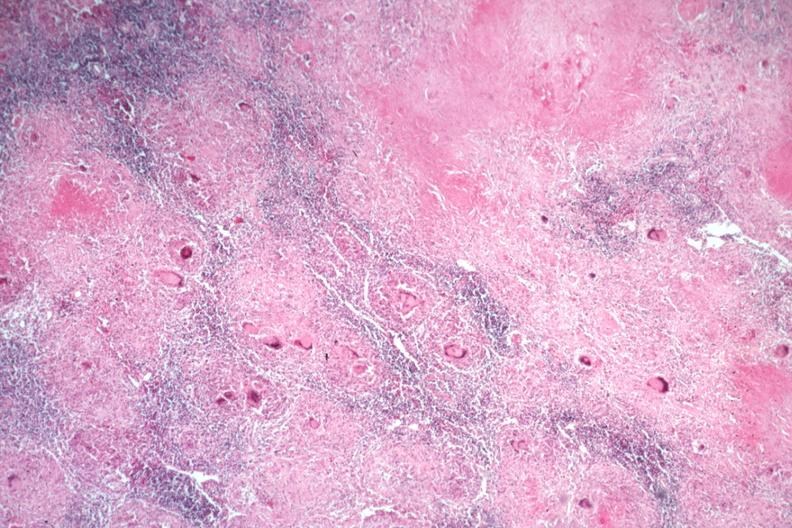what does this image show?
Answer the question using a single word or phrase. Typical caseating lesions with many langerhans giant cells 